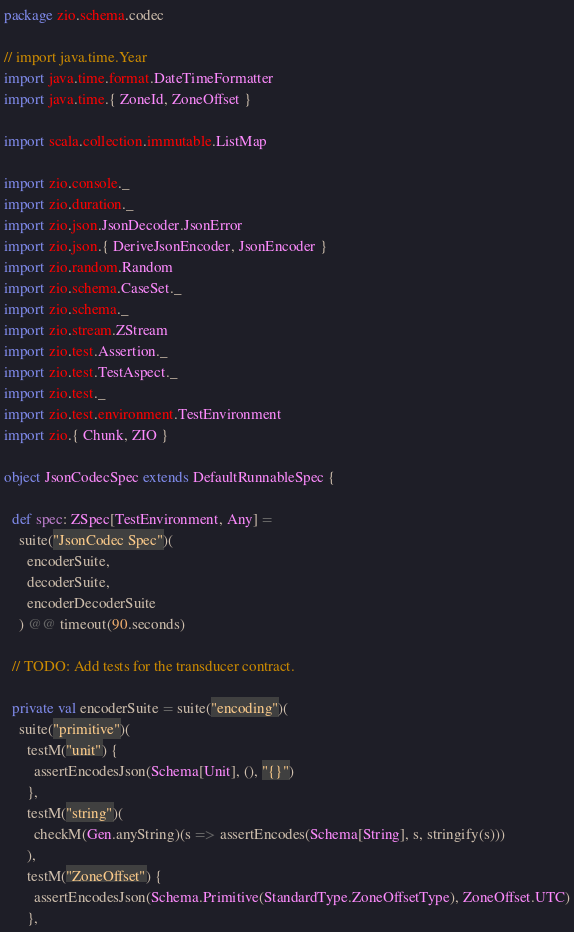<code> <loc_0><loc_0><loc_500><loc_500><_Scala_>package zio.schema.codec

// import java.time.Year
import java.time.format.DateTimeFormatter
import java.time.{ ZoneId, ZoneOffset }

import scala.collection.immutable.ListMap

import zio.console._
import zio.duration._
import zio.json.JsonDecoder.JsonError
import zio.json.{ DeriveJsonEncoder, JsonEncoder }
import zio.random.Random
import zio.schema.CaseSet._
import zio.schema._
import zio.stream.ZStream
import zio.test.Assertion._
import zio.test.TestAspect._
import zio.test._
import zio.test.environment.TestEnvironment
import zio.{ Chunk, ZIO }

object JsonCodecSpec extends DefaultRunnableSpec {

  def spec: ZSpec[TestEnvironment, Any] =
    suite("JsonCodec Spec")(
      encoderSuite,
      decoderSuite,
      encoderDecoderSuite
    ) @@ timeout(90.seconds)

  // TODO: Add tests for the transducer contract.

  private val encoderSuite = suite("encoding")(
    suite("primitive")(
      testM("unit") {
        assertEncodesJson(Schema[Unit], (), "{}")
      },
      testM("string")(
        checkM(Gen.anyString)(s => assertEncodes(Schema[String], s, stringify(s)))
      ),
      testM("ZoneOffset") {
        assertEncodesJson(Schema.Primitive(StandardType.ZoneOffsetType), ZoneOffset.UTC)
      },</code> 